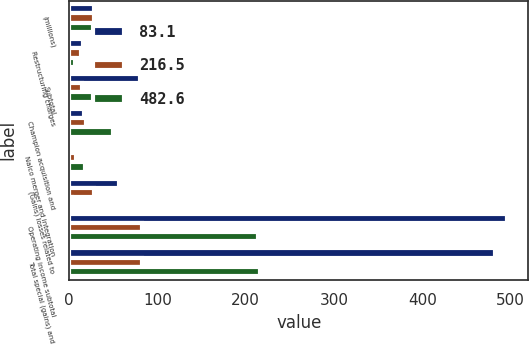<chart> <loc_0><loc_0><loc_500><loc_500><stacked_bar_chart><ecel><fcel>(millions)<fcel>Restructuring charges<fcel>Subtotal<fcel>Champion acquisition and<fcel>Nalco merger and integration<fcel>(Gains) losses related to<fcel>Operating income subtotal<fcel>Total special (gains) and<nl><fcel>83.1<fcel>28.8<fcel>16.5<fcel>80.6<fcel>17.1<fcel>1.6<fcel>56.3<fcel>495.4<fcel>482.6<nl><fcel>216.5<fcel>28.8<fcel>13.9<fcel>14.3<fcel>19.9<fcel>8.5<fcel>28.8<fcel>83.1<fcel>83.1<nl><fcel>482.6<fcel>28.8<fcel>6.6<fcel>43.2<fcel>49.7<fcel>18.6<fcel>3.6<fcel>214.5<fcel>216.5<nl></chart> 